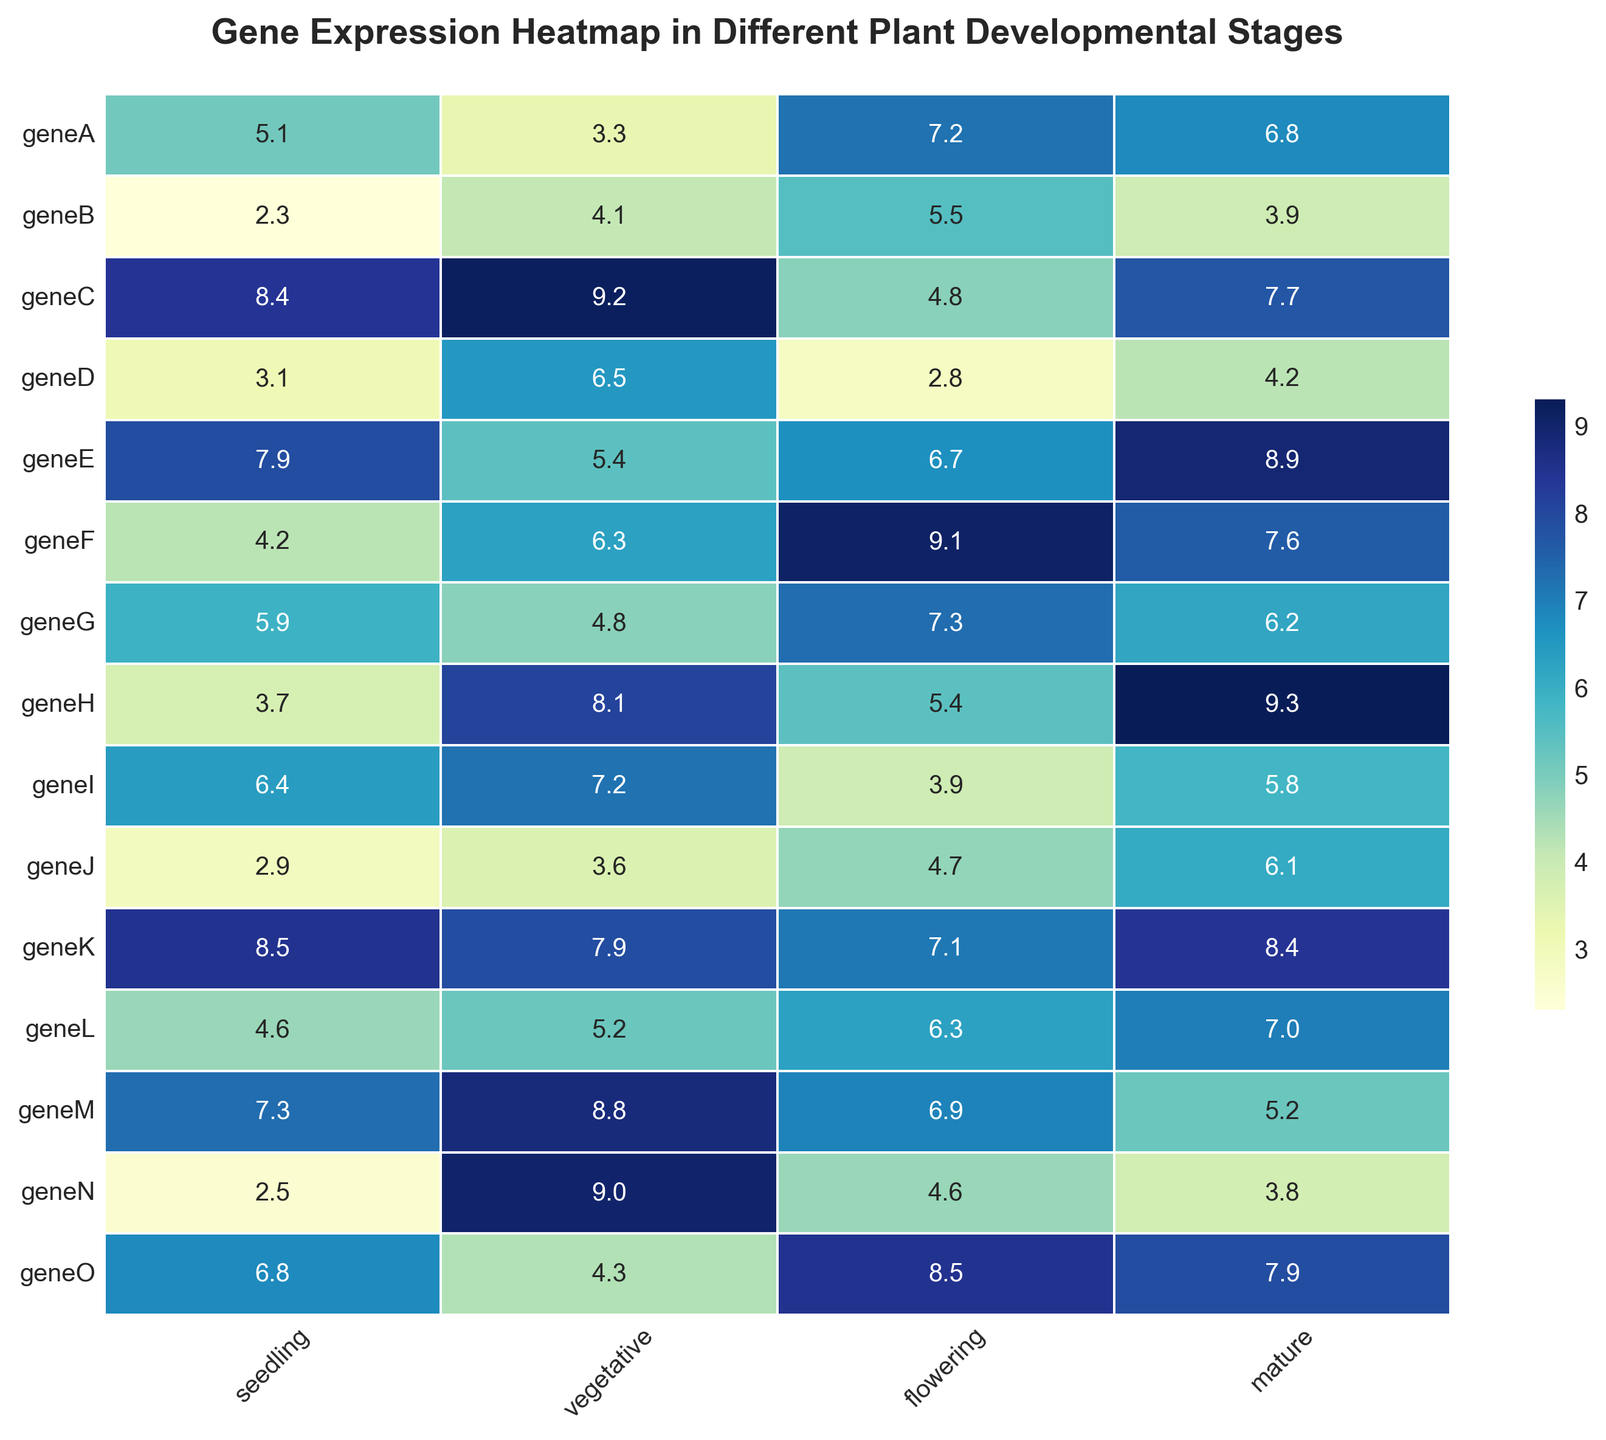What's the difference in gene expression of geneC between the vegetative and flowering stages? To find the difference, subtract the expression value in the flowering stage from the expression value in the vegetative stage for geneC: 9.2 - 4.8.
Answer: 4.4 Which gene shows the highest expression in the mature stage? To determine this, look at the column for mature stage values and identify the gene with the highest value. GeneH has the highest value at 9.3.
Answer: GeneH What is the average expression of geneL across all stages? Add the expression values of geneL across all stages and then divide by the number of stages: (4.6 + 5.2 + 6.3 + 7.0) / 4 = 23.1 / 4.
Answer: 5.8 Which gene shows the least variation in expression across all stages? To find this, look at the differences in expression values for each gene across all stages. GeneB has the smallest range from 2.3 to 5.5.
Answer: GeneB How does the expression of geneA in the seedling stage compare to geneD in the vegetative stage? Compare the seedling expression of geneA (5.1) with the vegetative expression of geneD (6.5). GeneD shows higher expression in the vegetative stage than geneA in the seedling stage.
Answer: GeneD is higher What's the total expression of geneK in the seedling and mature stages combined? Add the expression values of geneK in the seedling and mature stages: 8.5 + 8.4 = 16.9.
Answer: 16.9 Which developmental stage shows the highest average gene expression? First, calculate the average expression for each stage by summing the values of all genes for each stage and then dividing by the number of genes. The mature stage has the highest average.
Answer: Mature What's the median expression value of geneN across all developmental stages? Arrange the expression values of geneN in ascending order: 2.5, 3.8, 4.6, 9.0. Since there are four values, the median is the average of the two middle values: (3.8 + 4.6)/2 = 4.2.
Answer: 4.2 